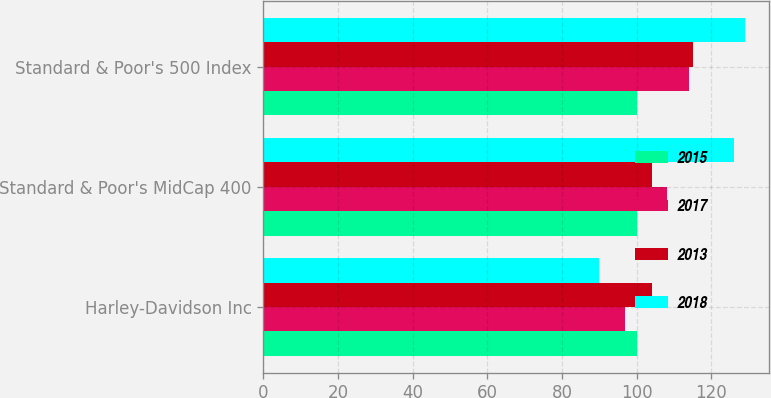Convert chart to OTSL. <chart><loc_0><loc_0><loc_500><loc_500><stacked_bar_chart><ecel><fcel>Harley-Davidson Inc<fcel>Standard & Poor's MidCap 400<fcel>Standard & Poor's 500 Index<nl><fcel>2015<fcel>100<fcel>100<fcel>100<nl><fcel>2017<fcel>97<fcel>108<fcel>114<nl><fcel>2013<fcel>104<fcel>104<fcel>115<nl><fcel>2018<fcel>90<fcel>126<fcel>129<nl></chart> 